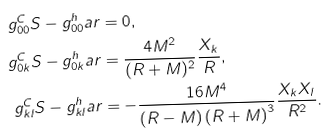Convert formula to latex. <formula><loc_0><loc_0><loc_500><loc_500>g _ { 0 0 } ^ { C } S - g _ { 0 0 } ^ { h } a r & = 0 , \\ g _ { 0 k } ^ { C } S - g _ { 0 k } ^ { h } a r & = \frac { 4 M ^ { 2 } } { ( R + M ) ^ { 2 } } \frac { X _ { k } } { R } , \\ g _ { k l } ^ { C } S - g _ { k l } ^ { h } a r & = - \frac { 1 6 M ^ { 4 } } { \left ( R - M \right ) \left ( R + M \right ) ^ { 3 } } \frac { X _ { k } X _ { l } } { R ^ { 2 } } .</formula> 